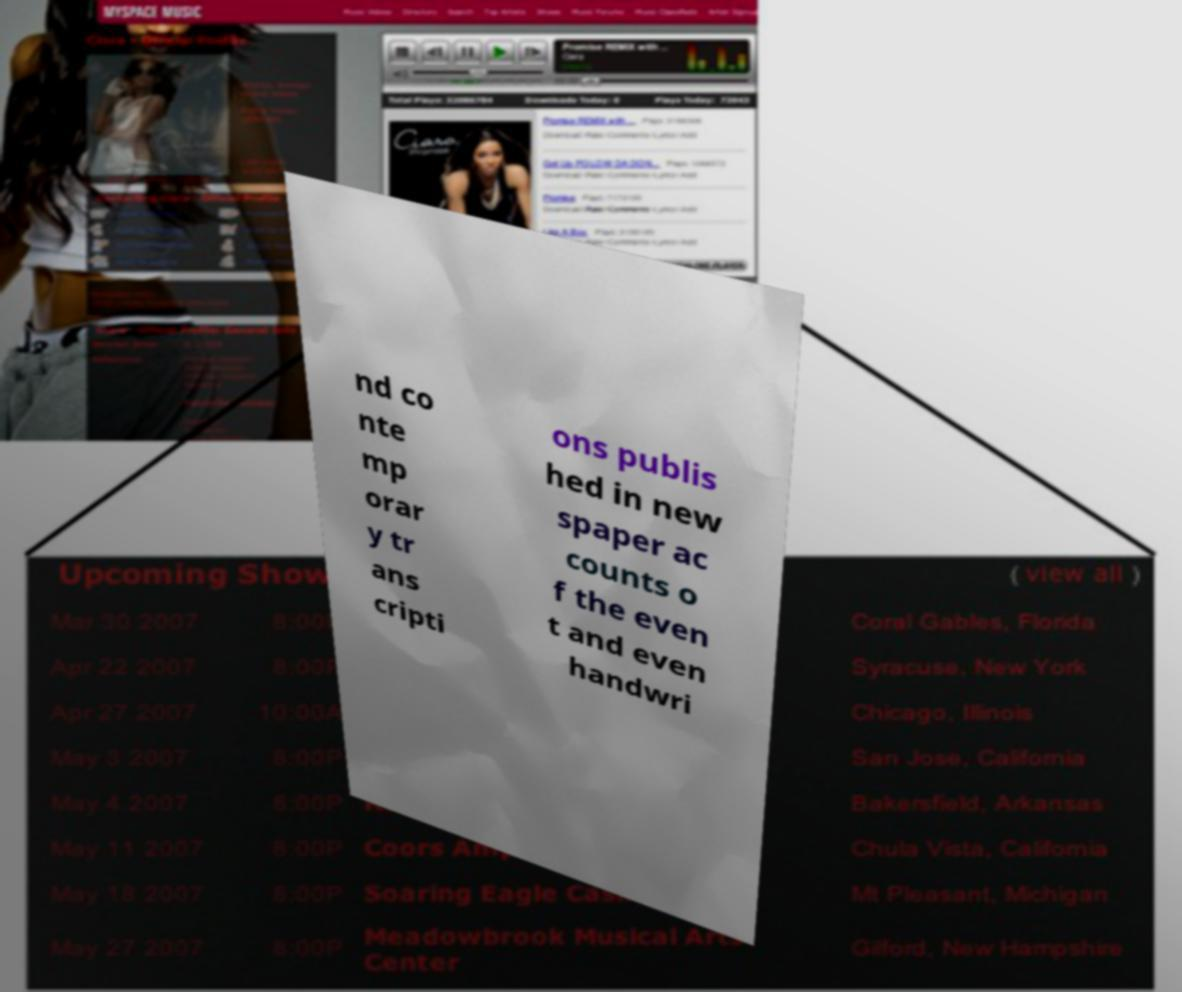Please read and relay the text visible in this image. What does it say? nd co nte mp orar y tr ans cripti ons publis hed in new spaper ac counts o f the even t and even handwri 